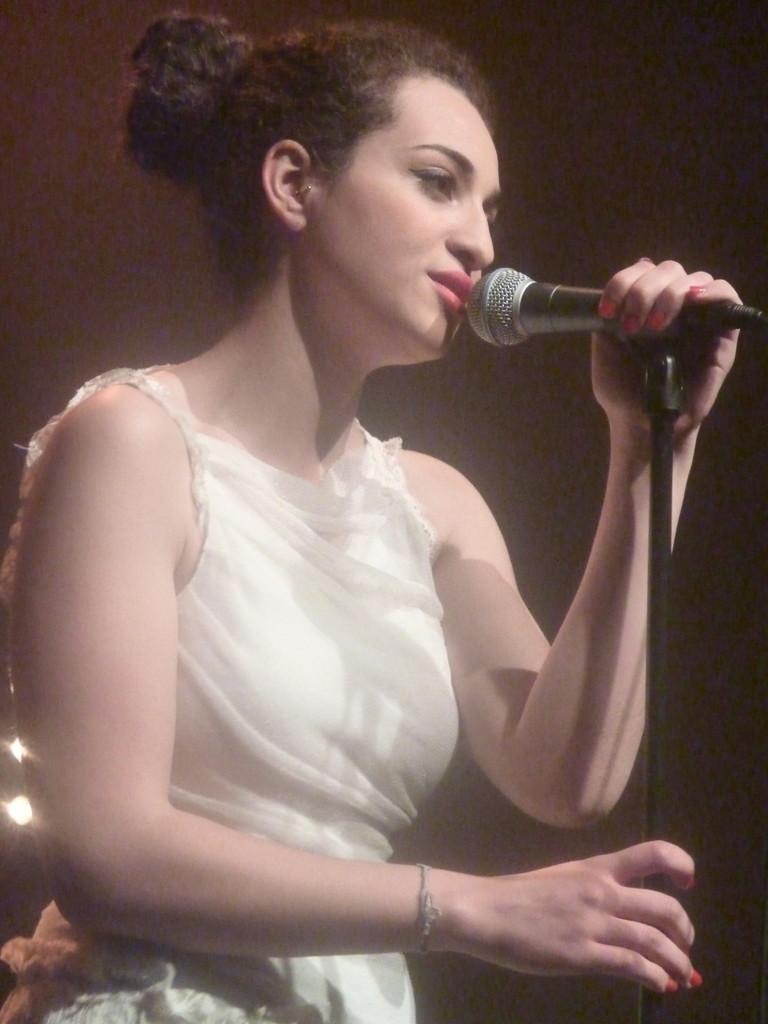Who is the main subject in the image? There is a woman in the image. What is the woman wearing? The woman is wearing a white dress. What is the woman holding in the image? The woman is holding a microphone. What is the woman doing with the microphone? The woman is singing into the microphone. What is the woman's level of anger in the image? There is no indication of the woman's emotional state, such as anger, in the image. 